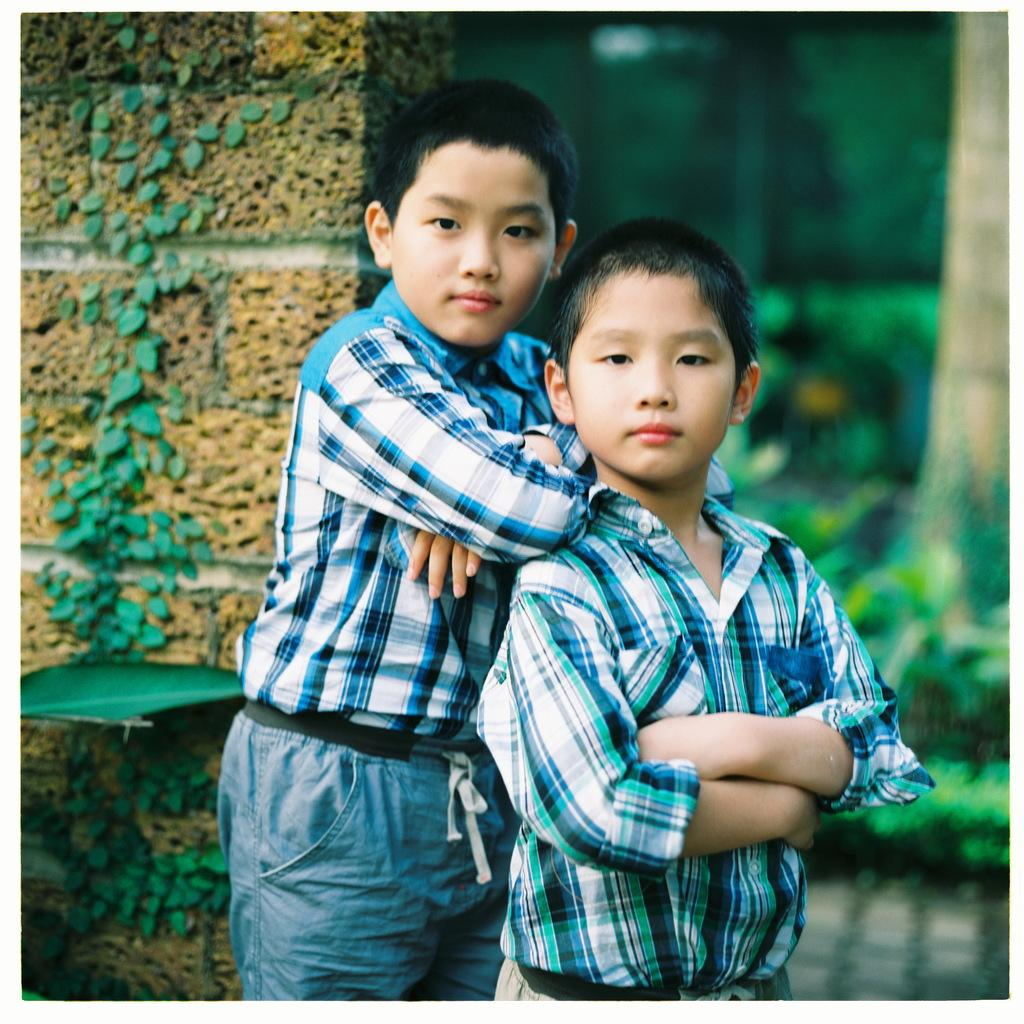How many people are present in the image? There are two persons standing in the image. What can be seen in the background of the image? There is a building, trees, and plants in the background of the image. What is on the wall on the left side of the image? There is a creeper on the wall on the left side of the image. What type of board can be seen being used by the crowd in the image? There is no crowd or board present in the image; it features two persons standing in front of a wall with a creeper. 